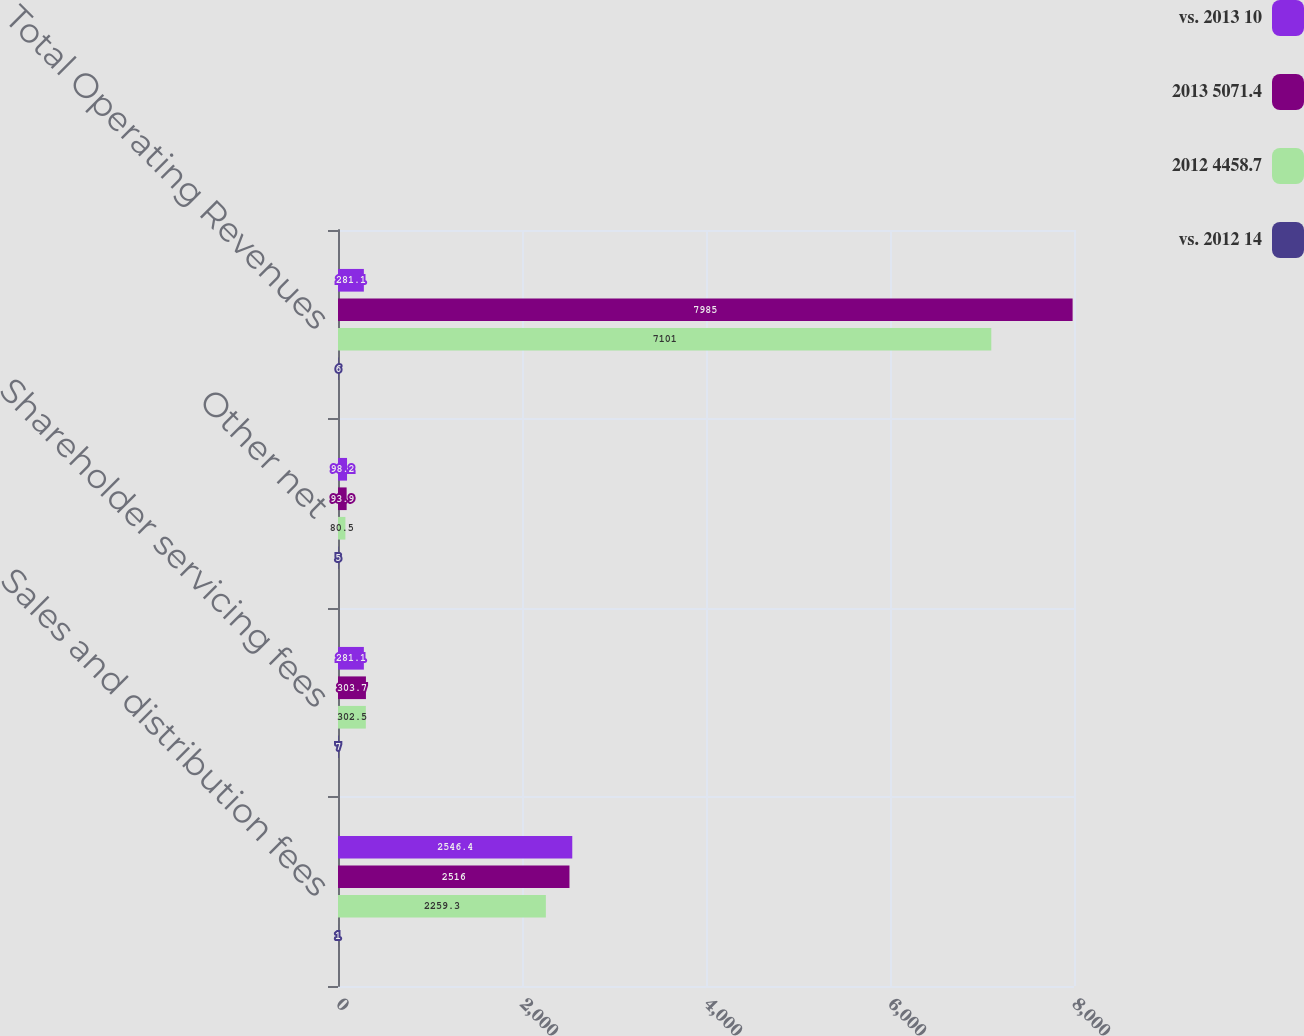<chart> <loc_0><loc_0><loc_500><loc_500><stacked_bar_chart><ecel><fcel>Sales and distribution fees<fcel>Shareholder servicing fees<fcel>Other net<fcel>Total Operating Revenues<nl><fcel>vs. 2013 10<fcel>2546.4<fcel>281.1<fcel>98.2<fcel>281.1<nl><fcel>2013 5071.4<fcel>2516<fcel>303.7<fcel>93.9<fcel>7985<nl><fcel>2012 4458.7<fcel>2259.3<fcel>302.5<fcel>80.5<fcel>7101<nl><fcel>vs. 2012 14<fcel>1<fcel>7<fcel>5<fcel>6<nl></chart> 